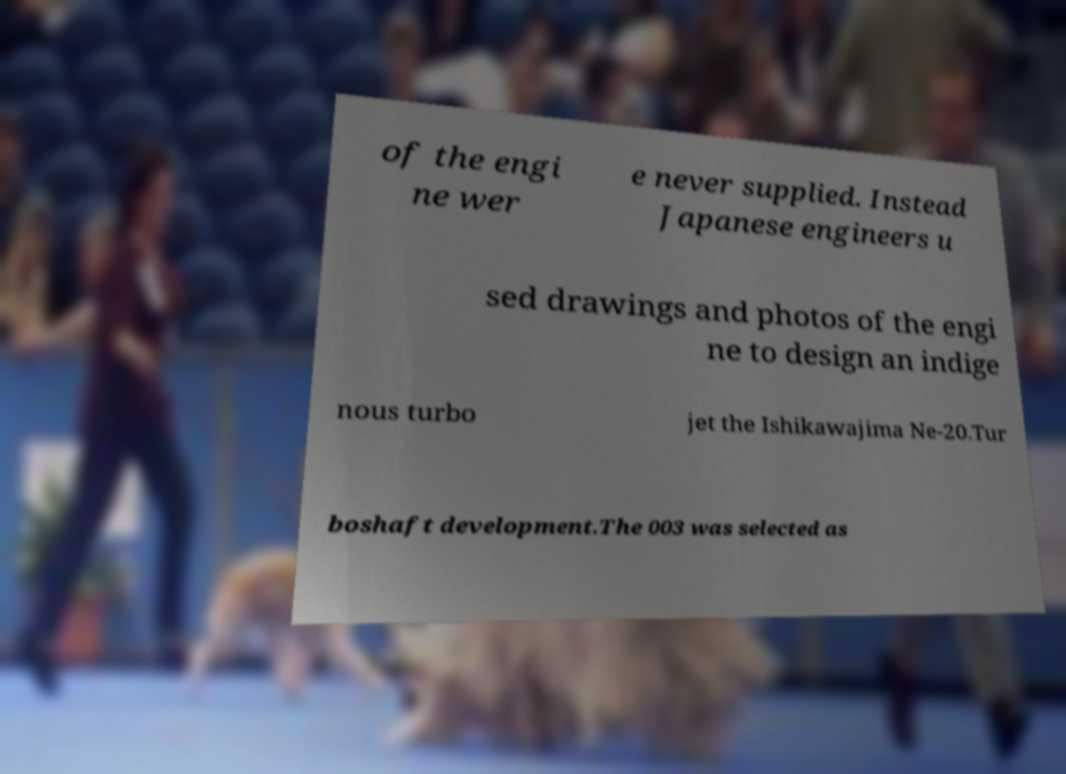Please read and relay the text visible in this image. What does it say? of the engi ne wer e never supplied. Instead Japanese engineers u sed drawings and photos of the engi ne to design an indige nous turbo jet the Ishikawajima Ne-20.Tur boshaft development.The 003 was selected as 